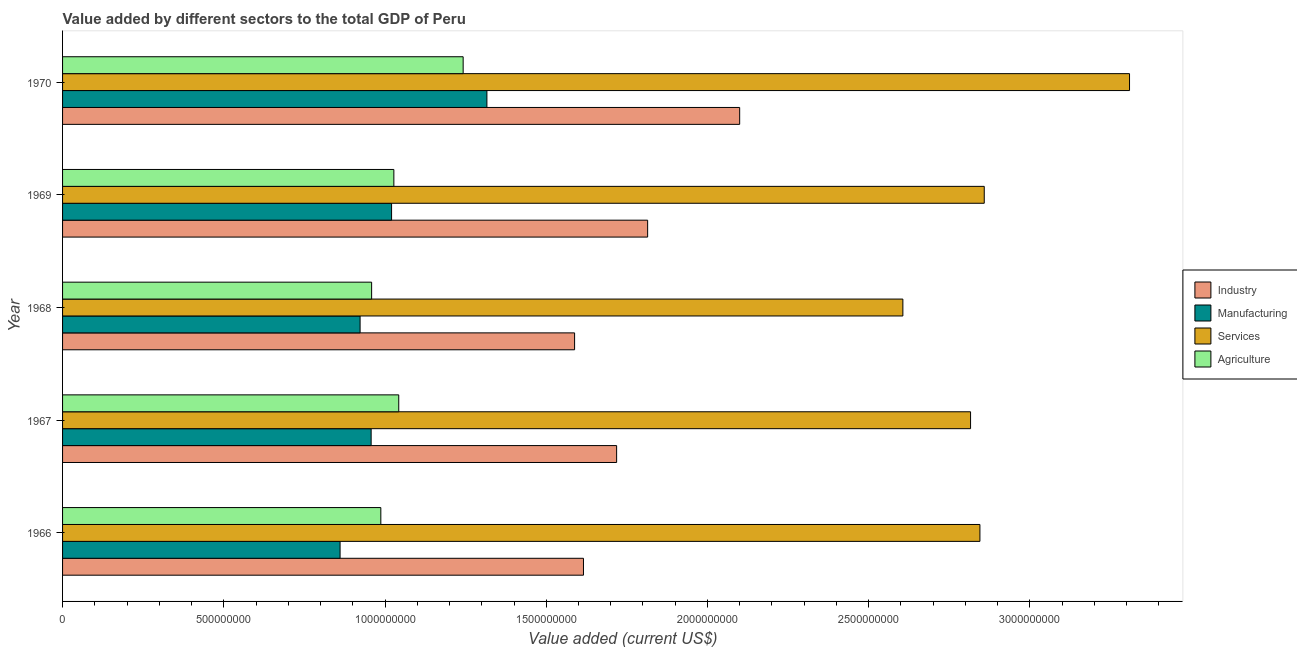Are the number of bars per tick equal to the number of legend labels?
Provide a short and direct response. Yes. How many bars are there on the 2nd tick from the top?
Provide a succinct answer. 4. What is the label of the 3rd group of bars from the top?
Offer a terse response. 1968. What is the value added by services sector in 1970?
Offer a terse response. 3.31e+09. Across all years, what is the maximum value added by agricultural sector?
Make the answer very short. 1.24e+09. Across all years, what is the minimum value added by manufacturing sector?
Your response must be concise. 8.61e+08. In which year was the value added by manufacturing sector minimum?
Ensure brevity in your answer.  1966. What is the total value added by agricultural sector in the graph?
Your answer should be very brief. 5.26e+09. What is the difference between the value added by industrial sector in 1969 and that in 1970?
Ensure brevity in your answer.  -2.85e+08. What is the difference between the value added by agricultural sector in 1966 and the value added by industrial sector in 1967?
Your answer should be compact. -7.31e+08. What is the average value added by services sector per year?
Keep it short and to the point. 2.89e+09. In the year 1966, what is the difference between the value added by manufacturing sector and value added by services sector?
Your answer should be compact. -1.98e+09. In how many years, is the value added by manufacturing sector greater than 1000000000 US$?
Offer a very short reply. 2. What is the ratio of the value added by manufacturing sector in 1968 to that in 1969?
Your answer should be very brief. 0.9. Is the value added by industrial sector in 1967 less than that in 1970?
Offer a terse response. Yes. Is the difference between the value added by services sector in 1966 and 1970 greater than the difference between the value added by agricultural sector in 1966 and 1970?
Your answer should be very brief. No. What is the difference between the highest and the second highest value added by industrial sector?
Your answer should be very brief. 2.85e+08. What is the difference between the highest and the lowest value added by manufacturing sector?
Provide a short and direct response. 4.55e+08. What does the 2nd bar from the top in 1969 represents?
Your answer should be very brief. Services. What does the 2nd bar from the bottom in 1967 represents?
Provide a short and direct response. Manufacturing. Is it the case that in every year, the sum of the value added by industrial sector and value added by manufacturing sector is greater than the value added by services sector?
Ensure brevity in your answer.  No. How many bars are there?
Offer a terse response. 20. Are all the bars in the graph horizontal?
Your answer should be compact. Yes. What is the difference between two consecutive major ticks on the X-axis?
Your answer should be very brief. 5.00e+08. How many legend labels are there?
Provide a succinct answer. 4. How are the legend labels stacked?
Make the answer very short. Vertical. What is the title of the graph?
Keep it short and to the point. Value added by different sectors to the total GDP of Peru. Does "Self-employed" appear as one of the legend labels in the graph?
Your response must be concise. No. What is the label or title of the X-axis?
Keep it short and to the point. Value added (current US$). What is the label or title of the Y-axis?
Offer a terse response. Year. What is the Value added (current US$) in Industry in 1966?
Provide a short and direct response. 1.62e+09. What is the Value added (current US$) in Manufacturing in 1966?
Your response must be concise. 8.61e+08. What is the Value added (current US$) in Services in 1966?
Your answer should be compact. 2.84e+09. What is the Value added (current US$) in Agriculture in 1966?
Your answer should be compact. 9.87e+08. What is the Value added (current US$) of Industry in 1967?
Your response must be concise. 1.72e+09. What is the Value added (current US$) of Manufacturing in 1967?
Offer a terse response. 9.57e+08. What is the Value added (current US$) in Services in 1967?
Provide a short and direct response. 2.82e+09. What is the Value added (current US$) of Agriculture in 1967?
Ensure brevity in your answer.  1.04e+09. What is the Value added (current US$) in Industry in 1968?
Ensure brevity in your answer.  1.59e+09. What is the Value added (current US$) of Manufacturing in 1968?
Make the answer very short. 9.23e+08. What is the Value added (current US$) of Services in 1968?
Your answer should be very brief. 2.61e+09. What is the Value added (current US$) in Agriculture in 1968?
Make the answer very short. 9.58e+08. What is the Value added (current US$) in Industry in 1969?
Provide a short and direct response. 1.81e+09. What is the Value added (current US$) in Manufacturing in 1969?
Give a very brief answer. 1.02e+09. What is the Value added (current US$) in Services in 1969?
Give a very brief answer. 2.86e+09. What is the Value added (current US$) in Agriculture in 1969?
Provide a succinct answer. 1.03e+09. What is the Value added (current US$) in Industry in 1970?
Ensure brevity in your answer.  2.10e+09. What is the Value added (current US$) of Manufacturing in 1970?
Your response must be concise. 1.32e+09. What is the Value added (current US$) in Services in 1970?
Ensure brevity in your answer.  3.31e+09. What is the Value added (current US$) of Agriculture in 1970?
Ensure brevity in your answer.  1.24e+09. Across all years, what is the maximum Value added (current US$) in Industry?
Provide a succinct answer. 2.10e+09. Across all years, what is the maximum Value added (current US$) of Manufacturing?
Your answer should be very brief. 1.32e+09. Across all years, what is the maximum Value added (current US$) in Services?
Provide a succinct answer. 3.31e+09. Across all years, what is the maximum Value added (current US$) in Agriculture?
Your answer should be compact. 1.24e+09. Across all years, what is the minimum Value added (current US$) in Industry?
Provide a short and direct response. 1.59e+09. Across all years, what is the minimum Value added (current US$) in Manufacturing?
Offer a terse response. 8.61e+08. Across all years, what is the minimum Value added (current US$) in Services?
Keep it short and to the point. 2.61e+09. Across all years, what is the minimum Value added (current US$) in Agriculture?
Offer a very short reply. 9.58e+08. What is the total Value added (current US$) of Industry in the graph?
Provide a succinct answer. 8.84e+09. What is the total Value added (current US$) of Manufacturing in the graph?
Provide a short and direct response. 5.08e+09. What is the total Value added (current US$) of Services in the graph?
Offer a very short reply. 1.44e+1. What is the total Value added (current US$) of Agriculture in the graph?
Give a very brief answer. 5.26e+09. What is the difference between the Value added (current US$) in Industry in 1966 and that in 1967?
Offer a very short reply. -1.03e+08. What is the difference between the Value added (current US$) of Manufacturing in 1966 and that in 1967?
Offer a terse response. -9.63e+07. What is the difference between the Value added (current US$) in Services in 1966 and that in 1967?
Offer a very short reply. 2.90e+07. What is the difference between the Value added (current US$) in Agriculture in 1966 and that in 1967?
Make the answer very short. -5.56e+07. What is the difference between the Value added (current US$) of Industry in 1966 and that in 1968?
Offer a terse response. 2.75e+07. What is the difference between the Value added (current US$) of Manufacturing in 1966 and that in 1968?
Your answer should be very brief. -6.21e+07. What is the difference between the Value added (current US$) of Services in 1966 and that in 1968?
Ensure brevity in your answer.  2.39e+08. What is the difference between the Value added (current US$) of Agriculture in 1966 and that in 1968?
Make the answer very short. 2.85e+07. What is the difference between the Value added (current US$) in Industry in 1966 and that in 1969?
Keep it short and to the point. -1.99e+08. What is the difference between the Value added (current US$) in Manufacturing in 1966 and that in 1969?
Your answer should be compact. -1.60e+08. What is the difference between the Value added (current US$) of Services in 1966 and that in 1969?
Give a very brief answer. -1.34e+07. What is the difference between the Value added (current US$) in Agriculture in 1966 and that in 1969?
Your response must be concise. -4.04e+07. What is the difference between the Value added (current US$) of Industry in 1966 and that in 1970?
Your response must be concise. -4.84e+08. What is the difference between the Value added (current US$) in Manufacturing in 1966 and that in 1970?
Provide a succinct answer. -4.55e+08. What is the difference between the Value added (current US$) in Services in 1966 and that in 1970?
Provide a succinct answer. -4.64e+08. What is the difference between the Value added (current US$) in Agriculture in 1966 and that in 1970?
Ensure brevity in your answer.  -2.55e+08. What is the difference between the Value added (current US$) of Industry in 1967 and that in 1968?
Offer a terse response. 1.30e+08. What is the difference between the Value added (current US$) of Manufacturing in 1967 and that in 1968?
Your response must be concise. 3.43e+07. What is the difference between the Value added (current US$) in Services in 1967 and that in 1968?
Ensure brevity in your answer.  2.10e+08. What is the difference between the Value added (current US$) in Agriculture in 1967 and that in 1968?
Your answer should be very brief. 8.41e+07. What is the difference between the Value added (current US$) of Industry in 1967 and that in 1969?
Give a very brief answer. -9.62e+07. What is the difference between the Value added (current US$) in Manufacturing in 1967 and that in 1969?
Make the answer very short. -6.33e+07. What is the difference between the Value added (current US$) in Services in 1967 and that in 1969?
Provide a succinct answer. -4.24e+07. What is the difference between the Value added (current US$) of Agriculture in 1967 and that in 1969?
Offer a very short reply. 1.52e+07. What is the difference between the Value added (current US$) in Industry in 1967 and that in 1970?
Make the answer very short. -3.82e+08. What is the difference between the Value added (current US$) in Manufacturing in 1967 and that in 1970?
Keep it short and to the point. -3.59e+08. What is the difference between the Value added (current US$) in Services in 1967 and that in 1970?
Your answer should be very brief. -4.93e+08. What is the difference between the Value added (current US$) in Agriculture in 1967 and that in 1970?
Your response must be concise. -2.00e+08. What is the difference between the Value added (current US$) in Industry in 1968 and that in 1969?
Offer a very short reply. -2.27e+08. What is the difference between the Value added (current US$) of Manufacturing in 1968 and that in 1969?
Keep it short and to the point. -9.76e+07. What is the difference between the Value added (current US$) in Services in 1968 and that in 1969?
Offer a terse response. -2.52e+08. What is the difference between the Value added (current US$) of Agriculture in 1968 and that in 1969?
Keep it short and to the point. -6.89e+07. What is the difference between the Value added (current US$) in Industry in 1968 and that in 1970?
Offer a very short reply. -5.12e+08. What is the difference between the Value added (current US$) in Manufacturing in 1968 and that in 1970?
Your answer should be compact. -3.93e+08. What is the difference between the Value added (current US$) in Services in 1968 and that in 1970?
Keep it short and to the point. -7.03e+08. What is the difference between the Value added (current US$) of Agriculture in 1968 and that in 1970?
Keep it short and to the point. -2.84e+08. What is the difference between the Value added (current US$) of Industry in 1969 and that in 1970?
Your response must be concise. -2.85e+08. What is the difference between the Value added (current US$) of Manufacturing in 1969 and that in 1970?
Make the answer very short. -2.96e+08. What is the difference between the Value added (current US$) in Services in 1969 and that in 1970?
Your answer should be compact. -4.51e+08. What is the difference between the Value added (current US$) in Agriculture in 1969 and that in 1970?
Ensure brevity in your answer.  -2.15e+08. What is the difference between the Value added (current US$) in Industry in 1966 and the Value added (current US$) in Manufacturing in 1967?
Give a very brief answer. 6.58e+08. What is the difference between the Value added (current US$) in Industry in 1966 and the Value added (current US$) in Services in 1967?
Your answer should be compact. -1.20e+09. What is the difference between the Value added (current US$) of Industry in 1966 and the Value added (current US$) of Agriculture in 1967?
Offer a very short reply. 5.73e+08. What is the difference between the Value added (current US$) of Manufacturing in 1966 and the Value added (current US$) of Services in 1967?
Keep it short and to the point. -1.96e+09. What is the difference between the Value added (current US$) of Manufacturing in 1966 and the Value added (current US$) of Agriculture in 1967?
Give a very brief answer. -1.82e+08. What is the difference between the Value added (current US$) in Services in 1966 and the Value added (current US$) in Agriculture in 1967?
Your answer should be very brief. 1.80e+09. What is the difference between the Value added (current US$) in Industry in 1966 and the Value added (current US$) in Manufacturing in 1968?
Offer a terse response. 6.93e+08. What is the difference between the Value added (current US$) in Industry in 1966 and the Value added (current US$) in Services in 1968?
Keep it short and to the point. -9.91e+08. What is the difference between the Value added (current US$) in Industry in 1966 and the Value added (current US$) in Agriculture in 1968?
Your response must be concise. 6.57e+08. What is the difference between the Value added (current US$) of Manufacturing in 1966 and the Value added (current US$) of Services in 1968?
Your answer should be compact. -1.75e+09. What is the difference between the Value added (current US$) of Manufacturing in 1966 and the Value added (current US$) of Agriculture in 1968?
Offer a very short reply. -9.78e+07. What is the difference between the Value added (current US$) of Services in 1966 and the Value added (current US$) of Agriculture in 1968?
Give a very brief answer. 1.89e+09. What is the difference between the Value added (current US$) in Industry in 1966 and the Value added (current US$) in Manufacturing in 1969?
Provide a succinct answer. 5.95e+08. What is the difference between the Value added (current US$) of Industry in 1966 and the Value added (current US$) of Services in 1969?
Your answer should be compact. -1.24e+09. What is the difference between the Value added (current US$) in Industry in 1966 and the Value added (current US$) in Agriculture in 1969?
Make the answer very short. 5.88e+08. What is the difference between the Value added (current US$) of Manufacturing in 1966 and the Value added (current US$) of Services in 1969?
Offer a terse response. -2.00e+09. What is the difference between the Value added (current US$) of Manufacturing in 1966 and the Value added (current US$) of Agriculture in 1969?
Offer a very short reply. -1.67e+08. What is the difference between the Value added (current US$) of Services in 1966 and the Value added (current US$) of Agriculture in 1969?
Your answer should be compact. 1.82e+09. What is the difference between the Value added (current US$) of Industry in 1966 and the Value added (current US$) of Manufacturing in 1970?
Your response must be concise. 2.99e+08. What is the difference between the Value added (current US$) in Industry in 1966 and the Value added (current US$) in Services in 1970?
Offer a terse response. -1.69e+09. What is the difference between the Value added (current US$) in Industry in 1966 and the Value added (current US$) in Agriculture in 1970?
Your answer should be very brief. 3.73e+08. What is the difference between the Value added (current US$) in Manufacturing in 1966 and the Value added (current US$) in Services in 1970?
Keep it short and to the point. -2.45e+09. What is the difference between the Value added (current US$) in Manufacturing in 1966 and the Value added (current US$) in Agriculture in 1970?
Make the answer very short. -3.82e+08. What is the difference between the Value added (current US$) of Services in 1966 and the Value added (current US$) of Agriculture in 1970?
Offer a terse response. 1.60e+09. What is the difference between the Value added (current US$) in Industry in 1967 and the Value added (current US$) in Manufacturing in 1968?
Your answer should be compact. 7.96e+08. What is the difference between the Value added (current US$) of Industry in 1967 and the Value added (current US$) of Services in 1968?
Provide a short and direct response. -8.88e+08. What is the difference between the Value added (current US$) of Industry in 1967 and the Value added (current US$) of Agriculture in 1968?
Ensure brevity in your answer.  7.60e+08. What is the difference between the Value added (current US$) of Manufacturing in 1967 and the Value added (current US$) of Services in 1968?
Provide a short and direct response. -1.65e+09. What is the difference between the Value added (current US$) in Manufacturing in 1967 and the Value added (current US$) in Agriculture in 1968?
Your answer should be compact. -1.49e+06. What is the difference between the Value added (current US$) of Services in 1967 and the Value added (current US$) of Agriculture in 1968?
Your answer should be very brief. 1.86e+09. What is the difference between the Value added (current US$) of Industry in 1967 and the Value added (current US$) of Manufacturing in 1969?
Offer a very short reply. 6.98e+08. What is the difference between the Value added (current US$) of Industry in 1967 and the Value added (current US$) of Services in 1969?
Your answer should be compact. -1.14e+09. What is the difference between the Value added (current US$) in Industry in 1967 and the Value added (current US$) in Agriculture in 1969?
Provide a short and direct response. 6.91e+08. What is the difference between the Value added (current US$) in Manufacturing in 1967 and the Value added (current US$) in Services in 1969?
Offer a very short reply. -1.90e+09. What is the difference between the Value added (current US$) of Manufacturing in 1967 and the Value added (current US$) of Agriculture in 1969?
Offer a very short reply. -7.04e+07. What is the difference between the Value added (current US$) in Services in 1967 and the Value added (current US$) in Agriculture in 1969?
Your answer should be very brief. 1.79e+09. What is the difference between the Value added (current US$) of Industry in 1967 and the Value added (current US$) of Manufacturing in 1970?
Your answer should be very brief. 4.02e+08. What is the difference between the Value added (current US$) in Industry in 1967 and the Value added (current US$) in Services in 1970?
Provide a succinct answer. -1.59e+09. What is the difference between the Value added (current US$) of Industry in 1967 and the Value added (current US$) of Agriculture in 1970?
Offer a very short reply. 4.76e+08. What is the difference between the Value added (current US$) in Manufacturing in 1967 and the Value added (current US$) in Services in 1970?
Keep it short and to the point. -2.35e+09. What is the difference between the Value added (current US$) in Manufacturing in 1967 and the Value added (current US$) in Agriculture in 1970?
Ensure brevity in your answer.  -2.85e+08. What is the difference between the Value added (current US$) in Services in 1967 and the Value added (current US$) in Agriculture in 1970?
Provide a succinct answer. 1.57e+09. What is the difference between the Value added (current US$) in Industry in 1968 and the Value added (current US$) in Manufacturing in 1969?
Offer a terse response. 5.68e+08. What is the difference between the Value added (current US$) of Industry in 1968 and the Value added (current US$) of Services in 1969?
Provide a short and direct response. -1.27e+09. What is the difference between the Value added (current US$) in Industry in 1968 and the Value added (current US$) in Agriculture in 1969?
Provide a short and direct response. 5.61e+08. What is the difference between the Value added (current US$) in Manufacturing in 1968 and the Value added (current US$) in Services in 1969?
Give a very brief answer. -1.94e+09. What is the difference between the Value added (current US$) of Manufacturing in 1968 and the Value added (current US$) of Agriculture in 1969?
Your response must be concise. -1.05e+08. What is the difference between the Value added (current US$) in Services in 1968 and the Value added (current US$) in Agriculture in 1969?
Your response must be concise. 1.58e+09. What is the difference between the Value added (current US$) in Industry in 1968 and the Value added (current US$) in Manufacturing in 1970?
Offer a very short reply. 2.72e+08. What is the difference between the Value added (current US$) of Industry in 1968 and the Value added (current US$) of Services in 1970?
Offer a terse response. -1.72e+09. What is the difference between the Value added (current US$) in Industry in 1968 and the Value added (current US$) in Agriculture in 1970?
Ensure brevity in your answer.  3.46e+08. What is the difference between the Value added (current US$) in Manufacturing in 1968 and the Value added (current US$) in Services in 1970?
Your answer should be very brief. -2.39e+09. What is the difference between the Value added (current US$) in Manufacturing in 1968 and the Value added (current US$) in Agriculture in 1970?
Offer a terse response. -3.20e+08. What is the difference between the Value added (current US$) of Services in 1968 and the Value added (current US$) of Agriculture in 1970?
Give a very brief answer. 1.36e+09. What is the difference between the Value added (current US$) of Industry in 1969 and the Value added (current US$) of Manufacturing in 1970?
Offer a very short reply. 4.98e+08. What is the difference between the Value added (current US$) of Industry in 1969 and the Value added (current US$) of Services in 1970?
Provide a short and direct response. -1.49e+09. What is the difference between the Value added (current US$) of Industry in 1969 and the Value added (current US$) of Agriculture in 1970?
Offer a very short reply. 5.72e+08. What is the difference between the Value added (current US$) in Manufacturing in 1969 and the Value added (current US$) in Services in 1970?
Your response must be concise. -2.29e+09. What is the difference between the Value added (current US$) of Manufacturing in 1969 and the Value added (current US$) of Agriculture in 1970?
Provide a succinct answer. -2.22e+08. What is the difference between the Value added (current US$) of Services in 1969 and the Value added (current US$) of Agriculture in 1970?
Ensure brevity in your answer.  1.62e+09. What is the average Value added (current US$) of Industry per year?
Offer a terse response. 1.77e+09. What is the average Value added (current US$) in Manufacturing per year?
Offer a terse response. 1.02e+09. What is the average Value added (current US$) in Services per year?
Make the answer very short. 2.89e+09. What is the average Value added (current US$) in Agriculture per year?
Ensure brevity in your answer.  1.05e+09. In the year 1966, what is the difference between the Value added (current US$) in Industry and Value added (current US$) in Manufacturing?
Give a very brief answer. 7.55e+08. In the year 1966, what is the difference between the Value added (current US$) in Industry and Value added (current US$) in Services?
Offer a terse response. -1.23e+09. In the year 1966, what is the difference between the Value added (current US$) of Industry and Value added (current US$) of Agriculture?
Offer a terse response. 6.28e+08. In the year 1966, what is the difference between the Value added (current US$) in Manufacturing and Value added (current US$) in Services?
Give a very brief answer. -1.98e+09. In the year 1966, what is the difference between the Value added (current US$) of Manufacturing and Value added (current US$) of Agriculture?
Offer a very short reply. -1.26e+08. In the year 1966, what is the difference between the Value added (current US$) in Services and Value added (current US$) in Agriculture?
Your response must be concise. 1.86e+09. In the year 1967, what is the difference between the Value added (current US$) of Industry and Value added (current US$) of Manufacturing?
Give a very brief answer. 7.61e+08. In the year 1967, what is the difference between the Value added (current US$) of Industry and Value added (current US$) of Services?
Offer a very short reply. -1.10e+09. In the year 1967, what is the difference between the Value added (current US$) in Industry and Value added (current US$) in Agriculture?
Provide a succinct answer. 6.76e+08. In the year 1967, what is the difference between the Value added (current US$) of Manufacturing and Value added (current US$) of Services?
Offer a terse response. -1.86e+09. In the year 1967, what is the difference between the Value added (current US$) of Manufacturing and Value added (current US$) of Agriculture?
Make the answer very short. -8.56e+07. In the year 1967, what is the difference between the Value added (current US$) in Services and Value added (current US$) in Agriculture?
Provide a succinct answer. 1.77e+09. In the year 1968, what is the difference between the Value added (current US$) of Industry and Value added (current US$) of Manufacturing?
Provide a short and direct response. 6.65e+08. In the year 1968, what is the difference between the Value added (current US$) in Industry and Value added (current US$) in Services?
Offer a terse response. -1.02e+09. In the year 1968, what is the difference between the Value added (current US$) of Industry and Value added (current US$) of Agriculture?
Your response must be concise. 6.29e+08. In the year 1968, what is the difference between the Value added (current US$) in Manufacturing and Value added (current US$) in Services?
Ensure brevity in your answer.  -1.68e+09. In the year 1968, what is the difference between the Value added (current US$) of Manufacturing and Value added (current US$) of Agriculture?
Keep it short and to the point. -3.58e+07. In the year 1968, what is the difference between the Value added (current US$) in Services and Value added (current US$) in Agriculture?
Provide a short and direct response. 1.65e+09. In the year 1969, what is the difference between the Value added (current US$) in Industry and Value added (current US$) in Manufacturing?
Your response must be concise. 7.94e+08. In the year 1969, what is the difference between the Value added (current US$) of Industry and Value added (current US$) of Services?
Give a very brief answer. -1.04e+09. In the year 1969, what is the difference between the Value added (current US$) of Industry and Value added (current US$) of Agriculture?
Provide a short and direct response. 7.87e+08. In the year 1969, what is the difference between the Value added (current US$) of Manufacturing and Value added (current US$) of Services?
Your answer should be very brief. -1.84e+09. In the year 1969, what is the difference between the Value added (current US$) in Manufacturing and Value added (current US$) in Agriculture?
Offer a very short reply. -7.07e+06. In the year 1969, what is the difference between the Value added (current US$) in Services and Value added (current US$) in Agriculture?
Give a very brief answer. 1.83e+09. In the year 1970, what is the difference between the Value added (current US$) of Industry and Value added (current US$) of Manufacturing?
Ensure brevity in your answer.  7.84e+08. In the year 1970, what is the difference between the Value added (current US$) in Industry and Value added (current US$) in Services?
Provide a succinct answer. -1.21e+09. In the year 1970, what is the difference between the Value added (current US$) of Industry and Value added (current US$) of Agriculture?
Provide a short and direct response. 8.58e+08. In the year 1970, what is the difference between the Value added (current US$) of Manufacturing and Value added (current US$) of Services?
Your response must be concise. -1.99e+09. In the year 1970, what is the difference between the Value added (current US$) of Manufacturing and Value added (current US$) of Agriculture?
Offer a terse response. 7.36e+07. In the year 1970, what is the difference between the Value added (current US$) of Services and Value added (current US$) of Agriculture?
Make the answer very short. 2.07e+09. What is the ratio of the Value added (current US$) in Industry in 1966 to that in 1967?
Provide a succinct answer. 0.94. What is the ratio of the Value added (current US$) of Manufacturing in 1966 to that in 1967?
Ensure brevity in your answer.  0.9. What is the ratio of the Value added (current US$) of Services in 1966 to that in 1967?
Give a very brief answer. 1.01. What is the ratio of the Value added (current US$) in Agriculture in 1966 to that in 1967?
Your answer should be compact. 0.95. What is the ratio of the Value added (current US$) of Industry in 1966 to that in 1968?
Give a very brief answer. 1.02. What is the ratio of the Value added (current US$) in Manufacturing in 1966 to that in 1968?
Provide a succinct answer. 0.93. What is the ratio of the Value added (current US$) in Services in 1966 to that in 1968?
Your answer should be very brief. 1.09. What is the ratio of the Value added (current US$) of Agriculture in 1966 to that in 1968?
Offer a very short reply. 1.03. What is the ratio of the Value added (current US$) of Industry in 1966 to that in 1969?
Your answer should be very brief. 0.89. What is the ratio of the Value added (current US$) of Manufacturing in 1966 to that in 1969?
Give a very brief answer. 0.84. What is the ratio of the Value added (current US$) of Agriculture in 1966 to that in 1969?
Offer a terse response. 0.96. What is the ratio of the Value added (current US$) of Industry in 1966 to that in 1970?
Your answer should be compact. 0.77. What is the ratio of the Value added (current US$) in Manufacturing in 1966 to that in 1970?
Your answer should be compact. 0.65. What is the ratio of the Value added (current US$) of Services in 1966 to that in 1970?
Give a very brief answer. 0.86. What is the ratio of the Value added (current US$) of Agriculture in 1966 to that in 1970?
Provide a short and direct response. 0.79. What is the ratio of the Value added (current US$) in Industry in 1967 to that in 1968?
Your answer should be compact. 1.08. What is the ratio of the Value added (current US$) of Manufacturing in 1967 to that in 1968?
Give a very brief answer. 1.04. What is the ratio of the Value added (current US$) of Services in 1967 to that in 1968?
Give a very brief answer. 1.08. What is the ratio of the Value added (current US$) in Agriculture in 1967 to that in 1968?
Offer a very short reply. 1.09. What is the ratio of the Value added (current US$) of Industry in 1967 to that in 1969?
Your answer should be very brief. 0.95. What is the ratio of the Value added (current US$) in Manufacturing in 1967 to that in 1969?
Offer a terse response. 0.94. What is the ratio of the Value added (current US$) of Services in 1967 to that in 1969?
Provide a short and direct response. 0.99. What is the ratio of the Value added (current US$) in Agriculture in 1967 to that in 1969?
Offer a very short reply. 1.01. What is the ratio of the Value added (current US$) in Industry in 1967 to that in 1970?
Offer a very short reply. 0.82. What is the ratio of the Value added (current US$) of Manufacturing in 1967 to that in 1970?
Give a very brief answer. 0.73. What is the ratio of the Value added (current US$) in Services in 1967 to that in 1970?
Your answer should be very brief. 0.85. What is the ratio of the Value added (current US$) of Agriculture in 1967 to that in 1970?
Give a very brief answer. 0.84. What is the ratio of the Value added (current US$) in Industry in 1968 to that in 1969?
Give a very brief answer. 0.88. What is the ratio of the Value added (current US$) in Manufacturing in 1968 to that in 1969?
Your response must be concise. 0.9. What is the ratio of the Value added (current US$) in Services in 1968 to that in 1969?
Provide a succinct answer. 0.91. What is the ratio of the Value added (current US$) in Agriculture in 1968 to that in 1969?
Your response must be concise. 0.93. What is the ratio of the Value added (current US$) of Industry in 1968 to that in 1970?
Offer a very short reply. 0.76. What is the ratio of the Value added (current US$) in Manufacturing in 1968 to that in 1970?
Your answer should be very brief. 0.7. What is the ratio of the Value added (current US$) in Services in 1968 to that in 1970?
Ensure brevity in your answer.  0.79. What is the ratio of the Value added (current US$) of Agriculture in 1968 to that in 1970?
Offer a terse response. 0.77. What is the ratio of the Value added (current US$) in Industry in 1969 to that in 1970?
Offer a very short reply. 0.86. What is the ratio of the Value added (current US$) of Manufacturing in 1969 to that in 1970?
Your response must be concise. 0.78. What is the ratio of the Value added (current US$) in Services in 1969 to that in 1970?
Your answer should be very brief. 0.86. What is the ratio of the Value added (current US$) in Agriculture in 1969 to that in 1970?
Keep it short and to the point. 0.83. What is the difference between the highest and the second highest Value added (current US$) of Industry?
Make the answer very short. 2.85e+08. What is the difference between the highest and the second highest Value added (current US$) in Manufacturing?
Your answer should be very brief. 2.96e+08. What is the difference between the highest and the second highest Value added (current US$) of Services?
Your response must be concise. 4.51e+08. What is the difference between the highest and the second highest Value added (current US$) in Agriculture?
Provide a short and direct response. 2.00e+08. What is the difference between the highest and the lowest Value added (current US$) of Industry?
Ensure brevity in your answer.  5.12e+08. What is the difference between the highest and the lowest Value added (current US$) in Manufacturing?
Offer a very short reply. 4.55e+08. What is the difference between the highest and the lowest Value added (current US$) in Services?
Your answer should be very brief. 7.03e+08. What is the difference between the highest and the lowest Value added (current US$) in Agriculture?
Make the answer very short. 2.84e+08. 